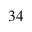Convert formula to latex. <formula><loc_0><loc_0><loc_500><loc_500>3 4</formula> 